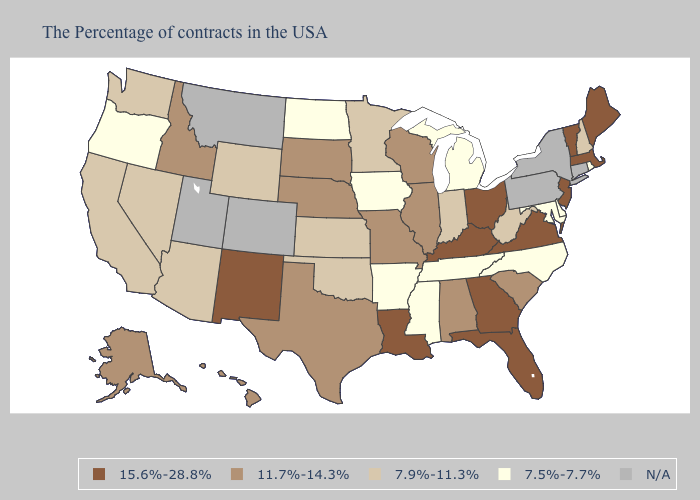Which states hav the highest value in the Northeast?
Short answer required. Maine, Massachusetts, Vermont, New Jersey. Among the states that border Connecticut , does Rhode Island have the highest value?
Answer briefly. No. Does the map have missing data?
Short answer required. Yes. Among the states that border Illinois , which have the lowest value?
Keep it brief. Iowa. What is the lowest value in the USA?
Keep it brief. 7.5%-7.7%. What is the value of Minnesota?
Keep it brief. 7.9%-11.3%. Name the states that have a value in the range 7.9%-11.3%?
Be succinct. New Hampshire, West Virginia, Indiana, Minnesota, Kansas, Oklahoma, Wyoming, Arizona, Nevada, California, Washington. Name the states that have a value in the range 7.5%-7.7%?
Quick response, please. Rhode Island, Delaware, Maryland, North Carolina, Michigan, Tennessee, Mississippi, Arkansas, Iowa, North Dakota, Oregon. Name the states that have a value in the range 11.7%-14.3%?
Concise answer only. South Carolina, Alabama, Wisconsin, Illinois, Missouri, Nebraska, Texas, South Dakota, Idaho, Alaska, Hawaii. Name the states that have a value in the range N/A?
Be succinct. Connecticut, New York, Pennsylvania, Colorado, Utah, Montana. Name the states that have a value in the range 15.6%-28.8%?
Be succinct. Maine, Massachusetts, Vermont, New Jersey, Virginia, Ohio, Florida, Georgia, Kentucky, Louisiana, New Mexico. Name the states that have a value in the range 7.9%-11.3%?
Write a very short answer. New Hampshire, West Virginia, Indiana, Minnesota, Kansas, Oklahoma, Wyoming, Arizona, Nevada, California, Washington. Does Kansas have the highest value in the MidWest?
Be succinct. No. Does Oregon have the lowest value in the USA?
Answer briefly. Yes. 